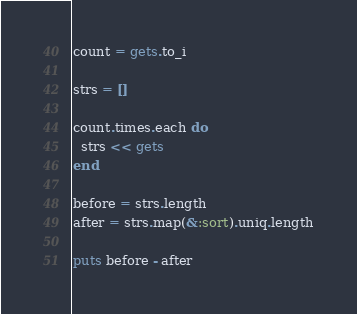<code> <loc_0><loc_0><loc_500><loc_500><_Ruby_>count = gets.to_i

strs = []

count.times.each do
  strs << gets
end

before = strs.length
after = strs.map(&:sort).uniq.length

puts before - after</code> 